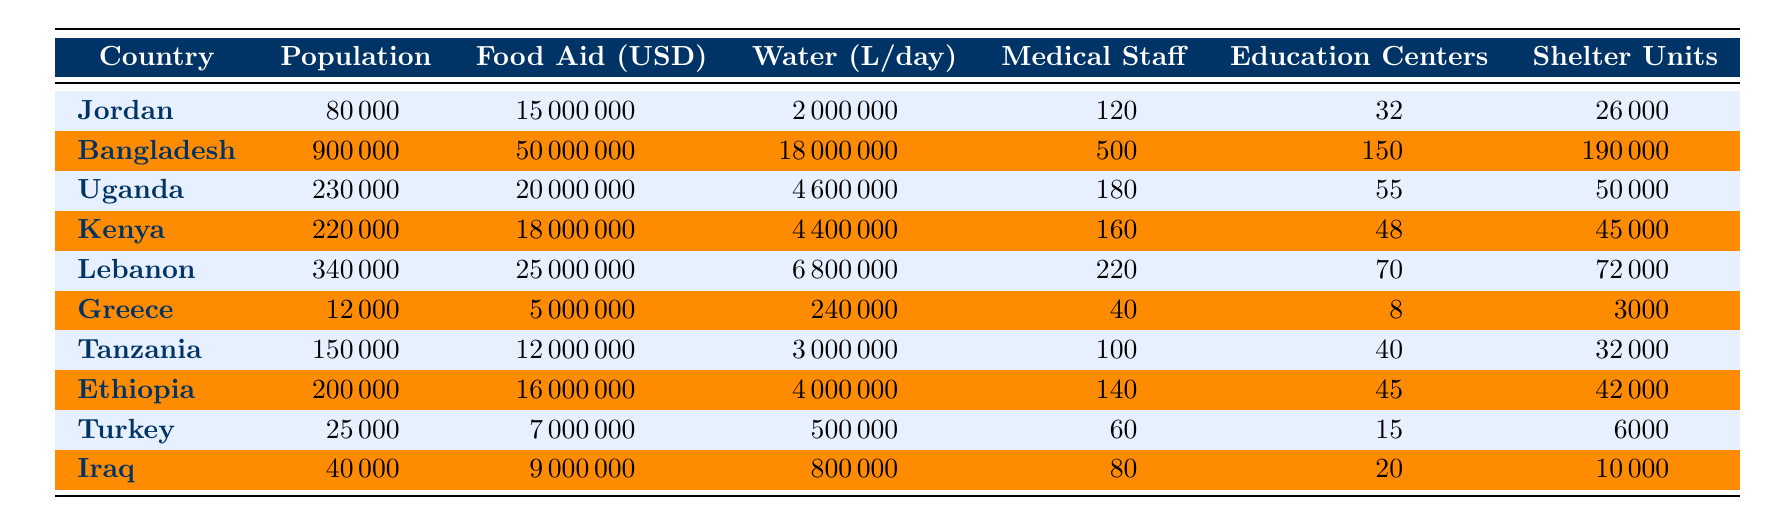What is the total population in the refugee camps listed? To find the total population, we add the population of all the camps: 80000 (Jordan) + 900000 (Bangladesh) + 230000 (Uganda) + 220000 (Kenya) + 340000 (Lebanon) + 12000 (Greece) + 150000 (Tanzania) + 200000 (Ethiopia) + 25000 (Turkey) + 40000 (Iraq) =  1962000.
Answer: 1962000 Which country has the highest Food Aid allocation? We compare the Food Aid allocations from all the countries: Bangladesh has 50000000, Lebanon has 25000000, and others have less. Bangladesh is the highest at 50000000.
Answer: Bangladesh How many Water liters per day are provided in total across all camps? The total water allocation can be computed by summing the daily water liters across all camps: 2000000 (Jordan) + 18000000 (Bangladesh) + 4600000 (Uganda) + 4400000 (Kenya) + 6800000 (Lebanon) + 240000 (Greece) + 3000000 (Tanzania) + 4000000 (Ethiopia) + 500000 (Turkey) + 800000 (Iraq) =  44000000.
Answer: 44000000 Is it true that each camp has more Medical Staff than Education Centers? For each camp, we compare the Medical Staff and Education Centers numbers: Jordan (120 vs 32), Bangladesh (500 vs 150), Uganda (180 vs 55), Kenya (160 vs 48), Lebanon (220 vs 70), Greece (40 vs 8), Tanzania (100 vs 40), Ethiopia (140 vs 45), Turkey (60 vs 15), Iraq (80 vs 20). All camps have more Medical Staff than Education Centers, so the answer is yes.
Answer: Yes What is the average number of Shelter Units across all camps? To find the average, we sum the Shelter Units: 26000 (Jordan) + 190000 (Bangladesh) + 50000 (Uganda) + 45000 (Kenya) + 72000 (Lebanon) + 3000 (Greece) + 32000 (Tanzania) + 42000 (Ethiopia) + 6000 (Turkey) + 10000 (Iraq) =  425000. Then, divide by 10 camps, giving us an average of 42500.
Answer: 42500 